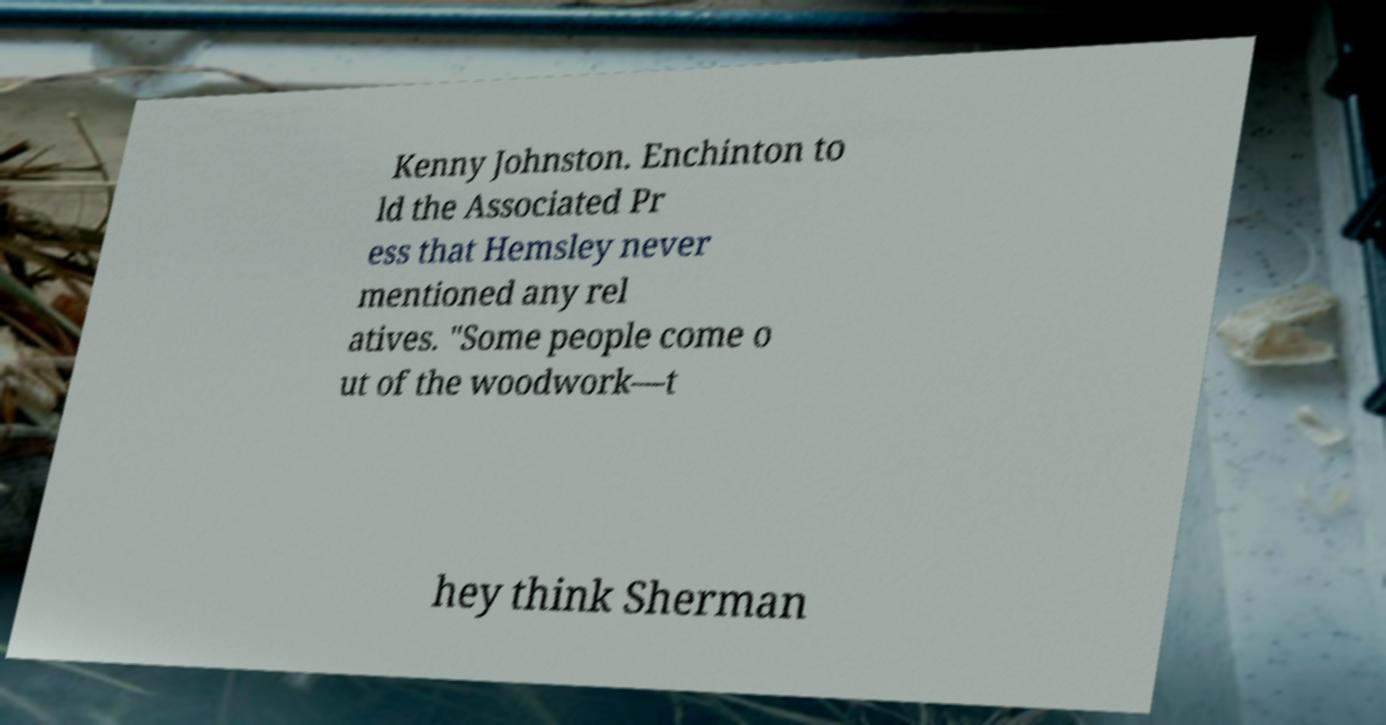Could you extract and type out the text from this image? Kenny Johnston. Enchinton to ld the Associated Pr ess that Hemsley never mentioned any rel atives. "Some people come o ut of the woodwork—t hey think Sherman 